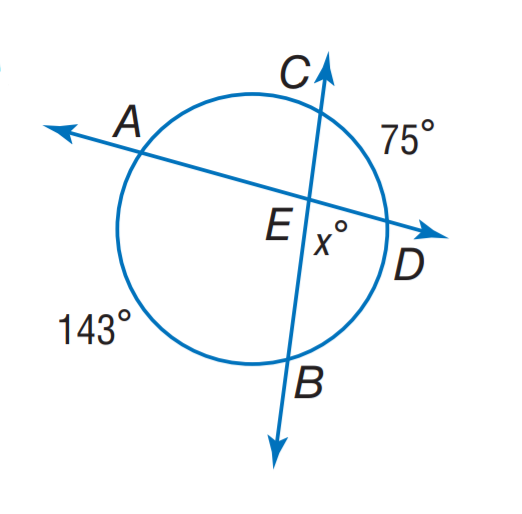Answer the mathemtical geometry problem and directly provide the correct option letter.
Question: Find x.
Choices: A: 71 B: 75 C: 109 D: 143 A 